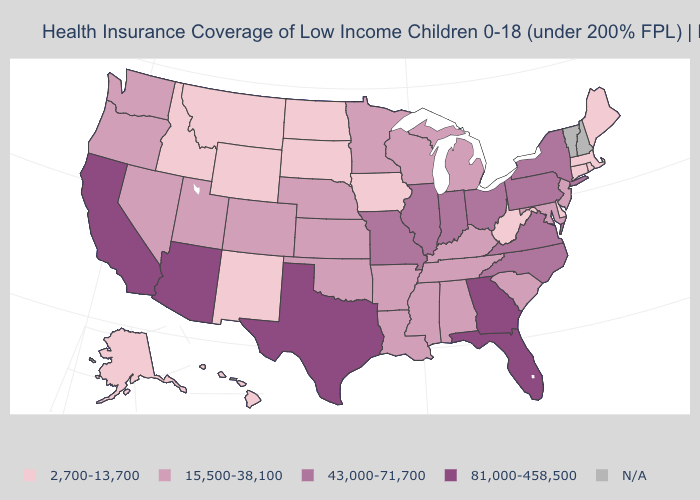Which states hav the highest value in the MidWest?
Concise answer only. Illinois, Indiana, Missouri, Ohio. What is the value of Texas?
Keep it brief. 81,000-458,500. Does Wyoming have the highest value in the USA?
Keep it brief. No. What is the value of Oregon?
Give a very brief answer. 15,500-38,100. Among the states that border West Virginia , which have the highest value?
Short answer required. Ohio, Pennsylvania, Virginia. Among the states that border Ohio , which have the lowest value?
Keep it brief. West Virginia. Does Arizona have the highest value in the USA?
Answer briefly. Yes. Name the states that have a value in the range 15,500-38,100?
Quick response, please. Alabama, Arkansas, Colorado, Kansas, Kentucky, Louisiana, Maryland, Michigan, Minnesota, Mississippi, Nebraska, Nevada, New Jersey, Oklahoma, Oregon, South Carolina, Tennessee, Utah, Washington, Wisconsin. Does the first symbol in the legend represent the smallest category?
Write a very short answer. Yes. What is the lowest value in the USA?
Write a very short answer. 2,700-13,700. Does West Virginia have the lowest value in the South?
Be succinct. Yes. What is the highest value in states that border Tennessee?
Be succinct. 81,000-458,500. What is the value of Hawaii?
Short answer required. 2,700-13,700. 